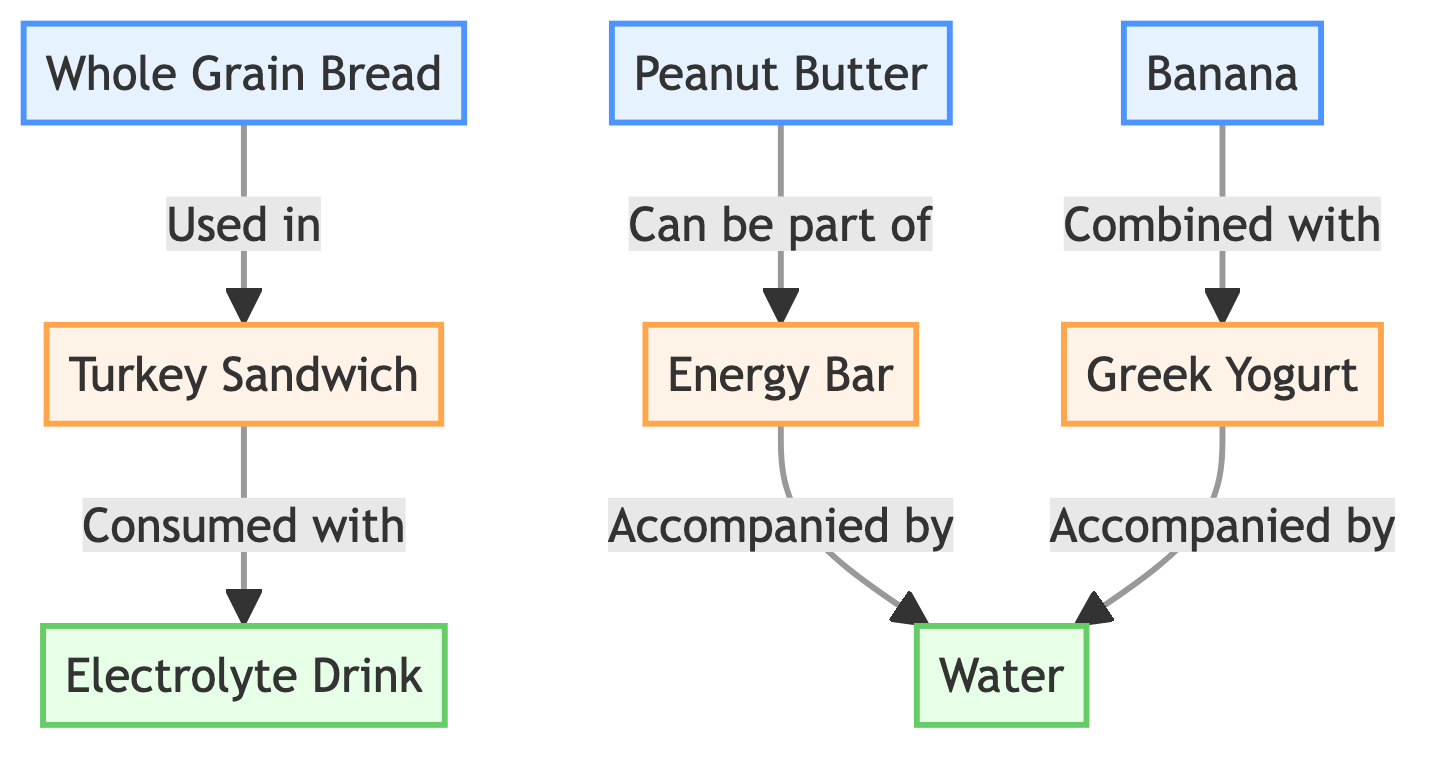What are the snacks present in the diagram? The diagram lists three snacks: Turkey Sandwich, Energy Bar, and Greek Yogurt.
Answer: Turkey Sandwich, Energy Bar, Greek Yogurt How many ingredients are used in the snacks represented in the diagram? There are three ingredients shown: Whole Grain Bread, Peanut Butter, and Banana. These ingredients contribute to the snacks represented.
Answer: 3 Which ingredient is used in the Turkey Sandwich? The diagram shows that Whole Grain Bread is used in the Turkey Sandwich.
Answer: Whole Grain Bread Which beverage is consumed with the Turkey Sandwich? According to the diagram, the Turkey Sandwich is consumed with the Electrolyte Drink.
Answer: Electrolyte Drink How many snacks are accompanied by Water? The diagram indicates that both the Energy Bar and Greek Yogurt are accompanied by Water. Therefore, the count is two snacks.
Answer: 2 What item can be part of the Energy Bar? The diagram shows that Peanut Butter can be part of the Energy Bar.
Answer: Peanut Butter Which ingredient is combined with Greek Yogurt? The diagram specifically states that Banana is combined with Greek Yogurt.
Answer: Banana What is the relationship between Energy Bar and Water? The diagram shows that the Energy Bar is accompanied by Water, indicating a direct relationship in terms of consumption.
Answer: Accompanied by What is one common aspect of the snacks in relation to beverages? The diagram shows that all snacks are either consumed with Electrolyte Drink or accompanied by Water, indicating a hydration aspect.
Answer: Hydration 